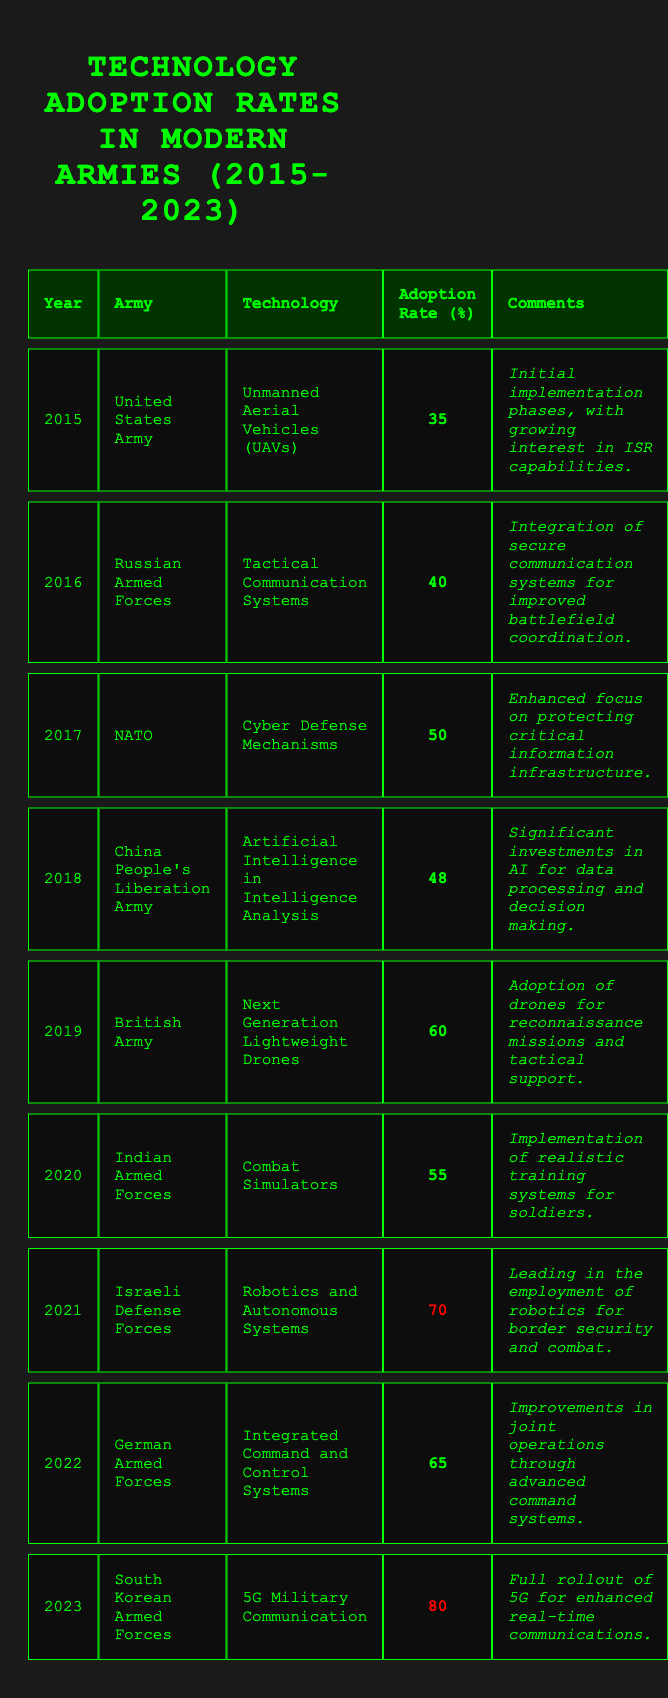What technology had the highest adoption rate in 2023? The table indicates that the South Korean Armed Forces had an adoption rate of 80% for 5G Military Communication in 2023, which is the highest among all listed technologies for that year.
Answer: 5G Military Communication Which army adopted Cyber Defense Mechanisms in 2017 and what was its adoption rate? According to the table, NATO adopted Cyber Defense Mechanisms in 2017 with an adoption rate of 50%.
Answer: NATO, 50% What was the average technology adoption rate from 2015 to 2020? To calculate the average, sum the adoption rates from 2015 (35) to 2020 (55) which gives us 35 + 40 + 50 + 48 + 60 + 55 = 288. There are 6 data points, so the average is 288/6 = 48.
Answer: 48 Did the Israeli Defense Forces have the highest adoption rate in 2021? The table shows that the Israeli Defense Forces had an adoption rate of 70% for Robotics and Autonomous Systems, which is higher than any other army's adoption rate listed for 2021.
Answer: Yes What technology experienced the biggest jump in adoption from its previous year? By analyzing the adoption rates, the largest increase was from 65% in 2022 (German Armed Forces) to 80% in 2023 (South Korean Armed Forces), a rise of 15%.
Answer: 15% increase for 5G Military Communication Which technology was adopted by the British Army in 2019 and what was its adoption rate? In 2019, the British Army adopted Next Generation Lightweight Drones, as indicated in the table, and the adoption rate was 60%.
Answer: Next Generation Lightweight Drones, 60% How many technologies had an adoption rate of 60% or higher from 2015 to 2023? From the table, the technologies with 60% or higher adoption rates are: Next Generation Lightweight Drones (60%), Robotics and Autonomous Systems (70%), Integrated Command and Control Systems (65%), and 5G Military Communication (80%). This totals 4 technologies.
Answer: 4 technologies What was the trend in adoption rates from 2015 to 2023? Reviewing the adoption rates from the table, we can observe a general upward trend as values rose from 35% in 2015 to 80% in 2023, indicating increasing adoption of advanced technologies in modern armies.
Answer: Upward trend Which year did the Russian Armed Forces adopt Tactical Communication Systems? The table indicates that the Russian Armed Forces adopted Tactical Communication Systems in 2016.
Answer: 2016 Overall, which army demonstrated the most significant advancement in technology adoption between 2015 and 2023? By calculating the improvement, the South Korean Armed Forces went from not listed in earlier years to 80% adoption in 2023, while other armies showed less dramatic increases. This indicates a significant advancement in technology adoption for South Korea within the given timeframe.
Answer: South Korean Armed Forces 